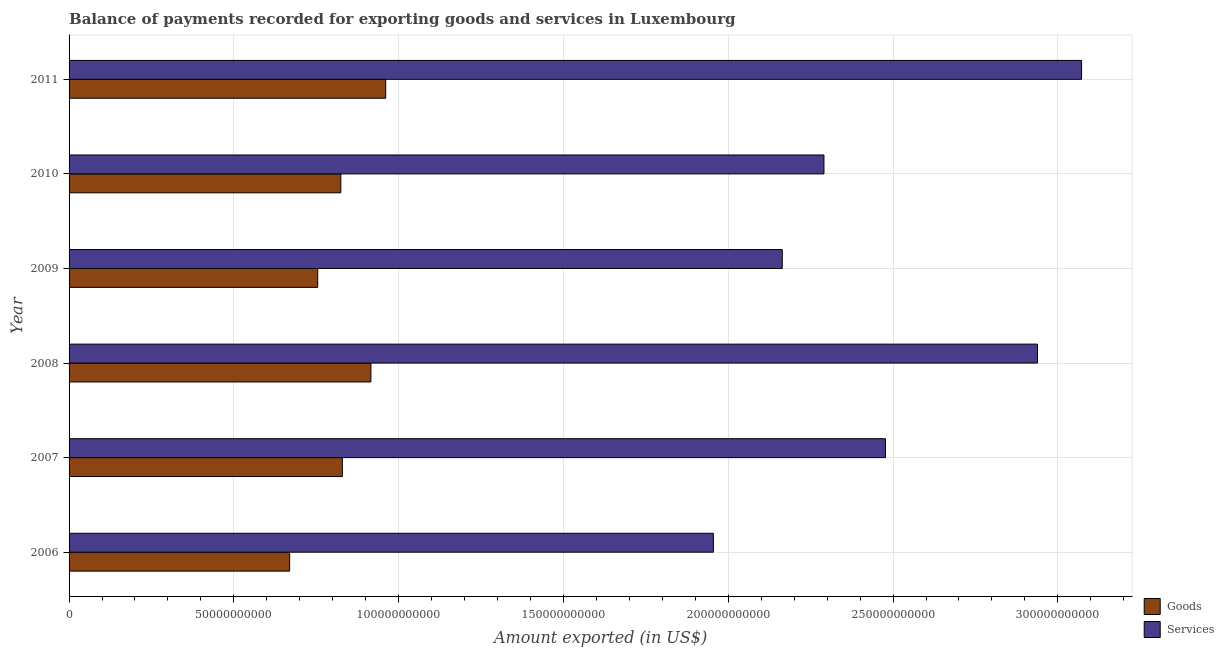Are the number of bars per tick equal to the number of legend labels?
Provide a short and direct response. Yes. Are the number of bars on each tick of the Y-axis equal?
Keep it short and to the point. Yes. How many bars are there on the 3rd tick from the top?
Give a very brief answer. 2. What is the label of the 4th group of bars from the top?
Provide a short and direct response. 2008. What is the amount of goods exported in 2008?
Your response must be concise. 9.16e+1. Across all years, what is the maximum amount of goods exported?
Your response must be concise. 9.61e+1. Across all years, what is the minimum amount of services exported?
Provide a short and direct response. 1.95e+11. What is the total amount of services exported in the graph?
Offer a very short reply. 1.49e+12. What is the difference between the amount of services exported in 2007 and that in 2009?
Make the answer very short. 3.13e+1. What is the difference between the amount of goods exported in 2008 and the amount of services exported in 2011?
Provide a short and direct response. -2.16e+11. What is the average amount of services exported per year?
Your answer should be very brief. 2.48e+11. In the year 2008, what is the difference between the amount of services exported and amount of goods exported?
Offer a terse response. 2.02e+11. In how many years, is the amount of services exported greater than 50000000000 US$?
Give a very brief answer. 6. What is the ratio of the amount of services exported in 2006 to that in 2009?
Provide a short and direct response. 0.9. Is the amount of goods exported in 2009 less than that in 2011?
Your answer should be very brief. Yes. Is the difference between the amount of goods exported in 2007 and 2008 greater than the difference between the amount of services exported in 2007 and 2008?
Give a very brief answer. Yes. What is the difference between the highest and the second highest amount of services exported?
Give a very brief answer. 1.34e+1. What is the difference between the highest and the lowest amount of goods exported?
Your response must be concise. 2.91e+1. Is the sum of the amount of goods exported in 2008 and 2011 greater than the maximum amount of services exported across all years?
Provide a short and direct response. No. What does the 2nd bar from the top in 2007 represents?
Give a very brief answer. Goods. What does the 1st bar from the bottom in 2006 represents?
Offer a very short reply. Goods. How many bars are there?
Offer a terse response. 12. Are all the bars in the graph horizontal?
Provide a short and direct response. Yes. Are the values on the major ticks of X-axis written in scientific E-notation?
Offer a very short reply. No. Does the graph contain any zero values?
Make the answer very short. No. Does the graph contain grids?
Your answer should be compact. Yes. Where does the legend appear in the graph?
Your answer should be compact. Bottom right. How many legend labels are there?
Your answer should be compact. 2. What is the title of the graph?
Provide a succinct answer. Balance of payments recorded for exporting goods and services in Luxembourg. Does "Age 65(female)" appear as one of the legend labels in the graph?
Make the answer very short. No. What is the label or title of the X-axis?
Offer a terse response. Amount exported (in US$). What is the Amount exported (in US$) of Goods in 2006?
Provide a short and direct response. 6.69e+1. What is the Amount exported (in US$) in Services in 2006?
Provide a succinct answer. 1.95e+11. What is the Amount exported (in US$) of Goods in 2007?
Your answer should be very brief. 8.29e+1. What is the Amount exported (in US$) of Services in 2007?
Ensure brevity in your answer.  2.48e+11. What is the Amount exported (in US$) of Goods in 2008?
Your answer should be very brief. 9.16e+1. What is the Amount exported (in US$) in Services in 2008?
Provide a succinct answer. 2.94e+11. What is the Amount exported (in US$) in Goods in 2009?
Provide a short and direct response. 7.54e+1. What is the Amount exported (in US$) in Services in 2009?
Your answer should be very brief. 2.16e+11. What is the Amount exported (in US$) of Goods in 2010?
Your response must be concise. 8.24e+1. What is the Amount exported (in US$) of Services in 2010?
Provide a short and direct response. 2.29e+11. What is the Amount exported (in US$) of Goods in 2011?
Your response must be concise. 9.61e+1. What is the Amount exported (in US$) of Services in 2011?
Keep it short and to the point. 3.07e+11. Across all years, what is the maximum Amount exported (in US$) of Goods?
Your response must be concise. 9.61e+1. Across all years, what is the maximum Amount exported (in US$) of Services?
Ensure brevity in your answer.  3.07e+11. Across all years, what is the minimum Amount exported (in US$) in Goods?
Offer a very short reply. 6.69e+1. Across all years, what is the minimum Amount exported (in US$) in Services?
Offer a very short reply. 1.95e+11. What is the total Amount exported (in US$) of Goods in the graph?
Your answer should be compact. 4.95e+11. What is the total Amount exported (in US$) in Services in the graph?
Give a very brief answer. 1.49e+12. What is the difference between the Amount exported (in US$) in Goods in 2006 and that in 2007?
Ensure brevity in your answer.  -1.60e+1. What is the difference between the Amount exported (in US$) of Services in 2006 and that in 2007?
Ensure brevity in your answer.  -5.22e+1. What is the difference between the Amount exported (in US$) in Goods in 2006 and that in 2008?
Provide a succinct answer. -2.47e+1. What is the difference between the Amount exported (in US$) in Services in 2006 and that in 2008?
Provide a short and direct response. -9.83e+1. What is the difference between the Amount exported (in US$) of Goods in 2006 and that in 2009?
Your answer should be very brief. -8.52e+09. What is the difference between the Amount exported (in US$) in Services in 2006 and that in 2009?
Your response must be concise. -2.09e+1. What is the difference between the Amount exported (in US$) of Goods in 2006 and that in 2010?
Your answer should be compact. -1.55e+1. What is the difference between the Amount exported (in US$) of Services in 2006 and that in 2010?
Provide a succinct answer. -3.35e+1. What is the difference between the Amount exported (in US$) in Goods in 2006 and that in 2011?
Your answer should be very brief. -2.91e+1. What is the difference between the Amount exported (in US$) in Services in 2006 and that in 2011?
Your answer should be very brief. -1.12e+11. What is the difference between the Amount exported (in US$) of Goods in 2007 and that in 2008?
Your answer should be very brief. -8.66e+09. What is the difference between the Amount exported (in US$) in Services in 2007 and that in 2008?
Provide a short and direct response. -4.61e+1. What is the difference between the Amount exported (in US$) in Goods in 2007 and that in 2009?
Provide a short and direct response. 7.48e+09. What is the difference between the Amount exported (in US$) in Services in 2007 and that in 2009?
Keep it short and to the point. 3.13e+1. What is the difference between the Amount exported (in US$) in Goods in 2007 and that in 2010?
Provide a short and direct response. 4.69e+08. What is the difference between the Amount exported (in US$) of Services in 2007 and that in 2010?
Your answer should be compact. 1.87e+1. What is the difference between the Amount exported (in US$) in Goods in 2007 and that in 2011?
Keep it short and to the point. -1.31e+1. What is the difference between the Amount exported (in US$) of Services in 2007 and that in 2011?
Make the answer very short. -5.95e+1. What is the difference between the Amount exported (in US$) of Goods in 2008 and that in 2009?
Provide a short and direct response. 1.61e+1. What is the difference between the Amount exported (in US$) of Services in 2008 and that in 2009?
Keep it short and to the point. 7.74e+1. What is the difference between the Amount exported (in US$) of Goods in 2008 and that in 2010?
Ensure brevity in your answer.  9.13e+09. What is the difference between the Amount exported (in US$) in Services in 2008 and that in 2010?
Make the answer very short. 6.48e+1. What is the difference between the Amount exported (in US$) in Goods in 2008 and that in 2011?
Offer a very short reply. -4.48e+09. What is the difference between the Amount exported (in US$) in Services in 2008 and that in 2011?
Offer a very short reply. -1.34e+1. What is the difference between the Amount exported (in US$) in Goods in 2009 and that in 2010?
Provide a succinct answer. -7.01e+09. What is the difference between the Amount exported (in US$) in Services in 2009 and that in 2010?
Make the answer very short. -1.26e+1. What is the difference between the Amount exported (in US$) in Goods in 2009 and that in 2011?
Make the answer very short. -2.06e+1. What is the difference between the Amount exported (in US$) of Services in 2009 and that in 2011?
Give a very brief answer. -9.08e+1. What is the difference between the Amount exported (in US$) of Goods in 2010 and that in 2011?
Keep it short and to the point. -1.36e+1. What is the difference between the Amount exported (in US$) of Services in 2010 and that in 2011?
Your response must be concise. -7.82e+1. What is the difference between the Amount exported (in US$) of Goods in 2006 and the Amount exported (in US$) of Services in 2007?
Provide a succinct answer. -1.81e+11. What is the difference between the Amount exported (in US$) in Goods in 2006 and the Amount exported (in US$) in Services in 2008?
Provide a short and direct response. -2.27e+11. What is the difference between the Amount exported (in US$) of Goods in 2006 and the Amount exported (in US$) of Services in 2009?
Offer a terse response. -1.49e+11. What is the difference between the Amount exported (in US$) of Goods in 2006 and the Amount exported (in US$) of Services in 2010?
Offer a terse response. -1.62e+11. What is the difference between the Amount exported (in US$) of Goods in 2006 and the Amount exported (in US$) of Services in 2011?
Offer a very short reply. -2.40e+11. What is the difference between the Amount exported (in US$) in Goods in 2007 and the Amount exported (in US$) in Services in 2008?
Keep it short and to the point. -2.11e+11. What is the difference between the Amount exported (in US$) of Goods in 2007 and the Amount exported (in US$) of Services in 2009?
Offer a very short reply. -1.33e+11. What is the difference between the Amount exported (in US$) of Goods in 2007 and the Amount exported (in US$) of Services in 2010?
Offer a very short reply. -1.46e+11. What is the difference between the Amount exported (in US$) of Goods in 2007 and the Amount exported (in US$) of Services in 2011?
Offer a very short reply. -2.24e+11. What is the difference between the Amount exported (in US$) of Goods in 2008 and the Amount exported (in US$) of Services in 2009?
Make the answer very short. -1.25e+11. What is the difference between the Amount exported (in US$) of Goods in 2008 and the Amount exported (in US$) of Services in 2010?
Offer a terse response. -1.37e+11. What is the difference between the Amount exported (in US$) in Goods in 2008 and the Amount exported (in US$) in Services in 2011?
Offer a terse response. -2.16e+11. What is the difference between the Amount exported (in US$) of Goods in 2009 and the Amount exported (in US$) of Services in 2010?
Make the answer very short. -1.54e+11. What is the difference between the Amount exported (in US$) in Goods in 2009 and the Amount exported (in US$) in Services in 2011?
Give a very brief answer. -2.32e+11. What is the difference between the Amount exported (in US$) in Goods in 2010 and the Amount exported (in US$) in Services in 2011?
Your response must be concise. -2.25e+11. What is the average Amount exported (in US$) of Goods per year?
Your answer should be very brief. 8.26e+1. What is the average Amount exported (in US$) of Services per year?
Your answer should be compact. 2.48e+11. In the year 2006, what is the difference between the Amount exported (in US$) in Goods and Amount exported (in US$) in Services?
Your answer should be compact. -1.29e+11. In the year 2007, what is the difference between the Amount exported (in US$) of Goods and Amount exported (in US$) of Services?
Provide a short and direct response. -1.65e+11. In the year 2008, what is the difference between the Amount exported (in US$) in Goods and Amount exported (in US$) in Services?
Offer a very short reply. -2.02e+11. In the year 2009, what is the difference between the Amount exported (in US$) in Goods and Amount exported (in US$) in Services?
Ensure brevity in your answer.  -1.41e+11. In the year 2010, what is the difference between the Amount exported (in US$) in Goods and Amount exported (in US$) in Services?
Ensure brevity in your answer.  -1.47e+11. In the year 2011, what is the difference between the Amount exported (in US$) of Goods and Amount exported (in US$) of Services?
Your answer should be very brief. -2.11e+11. What is the ratio of the Amount exported (in US$) of Goods in 2006 to that in 2007?
Provide a short and direct response. 0.81. What is the ratio of the Amount exported (in US$) of Services in 2006 to that in 2007?
Ensure brevity in your answer.  0.79. What is the ratio of the Amount exported (in US$) of Goods in 2006 to that in 2008?
Your answer should be very brief. 0.73. What is the ratio of the Amount exported (in US$) of Services in 2006 to that in 2008?
Offer a terse response. 0.67. What is the ratio of the Amount exported (in US$) in Goods in 2006 to that in 2009?
Give a very brief answer. 0.89. What is the ratio of the Amount exported (in US$) in Services in 2006 to that in 2009?
Keep it short and to the point. 0.9. What is the ratio of the Amount exported (in US$) of Goods in 2006 to that in 2010?
Offer a terse response. 0.81. What is the ratio of the Amount exported (in US$) of Services in 2006 to that in 2010?
Your answer should be very brief. 0.85. What is the ratio of the Amount exported (in US$) in Goods in 2006 to that in 2011?
Your answer should be very brief. 0.7. What is the ratio of the Amount exported (in US$) of Services in 2006 to that in 2011?
Your answer should be compact. 0.64. What is the ratio of the Amount exported (in US$) in Goods in 2007 to that in 2008?
Make the answer very short. 0.91. What is the ratio of the Amount exported (in US$) in Services in 2007 to that in 2008?
Ensure brevity in your answer.  0.84. What is the ratio of the Amount exported (in US$) in Goods in 2007 to that in 2009?
Provide a succinct answer. 1.1. What is the ratio of the Amount exported (in US$) in Services in 2007 to that in 2009?
Give a very brief answer. 1.14. What is the ratio of the Amount exported (in US$) of Services in 2007 to that in 2010?
Make the answer very short. 1.08. What is the ratio of the Amount exported (in US$) in Goods in 2007 to that in 2011?
Make the answer very short. 0.86. What is the ratio of the Amount exported (in US$) of Services in 2007 to that in 2011?
Give a very brief answer. 0.81. What is the ratio of the Amount exported (in US$) of Goods in 2008 to that in 2009?
Your answer should be very brief. 1.21. What is the ratio of the Amount exported (in US$) of Services in 2008 to that in 2009?
Give a very brief answer. 1.36. What is the ratio of the Amount exported (in US$) in Goods in 2008 to that in 2010?
Your answer should be compact. 1.11. What is the ratio of the Amount exported (in US$) in Services in 2008 to that in 2010?
Your answer should be very brief. 1.28. What is the ratio of the Amount exported (in US$) of Goods in 2008 to that in 2011?
Make the answer very short. 0.95. What is the ratio of the Amount exported (in US$) in Services in 2008 to that in 2011?
Provide a short and direct response. 0.96. What is the ratio of the Amount exported (in US$) of Goods in 2009 to that in 2010?
Your answer should be compact. 0.92. What is the ratio of the Amount exported (in US$) in Services in 2009 to that in 2010?
Your response must be concise. 0.94. What is the ratio of the Amount exported (in US$) of Goods in 2009 to that in 2011?
Offer a very short reply. 0.79. What is the ratio of the Amount exported (in US$) of Services in 2009 to that in 2011?
Your answer should be very brief. 0.7. What is the ratio of the Amount exported (in US$) of Goods in 2010 to that in 2011?
Your response must be concise. 0.86. What is the ratio of the Amount exported (in US$) in Services in 2010 to that in 2011?
Keep it short and to the point. 0.75. What is the difference between the highest and the second highest Amount exported (in US$) in Goods?
Provide a short and direct response. 4.48e+09. What is the difference between the highest and the second highest Amount exported (in US$) of Services?
Keep it short and to the point. 1.34e+1. What is the difference between the highest and the lowest Amount exported (in US$) in Goods?
Keep it short and to the point. 2.91e+1. What is the difference between the highest and the lowest Amount exported (in US$) in Services?
Offer a terse response. 1.12e+11. 